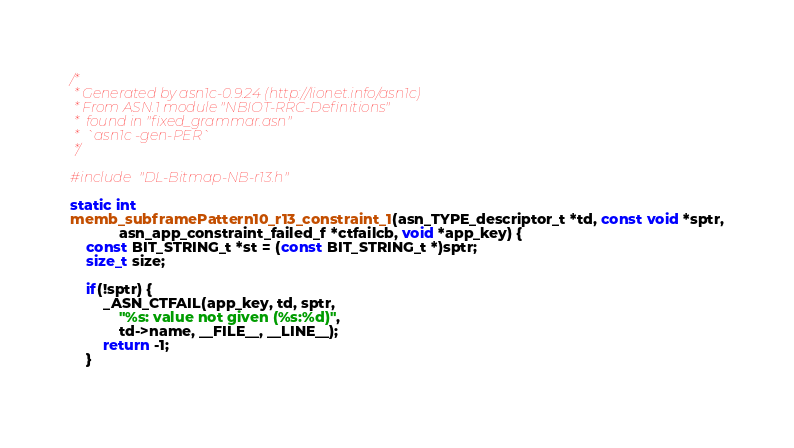<code> <loc_0><loc_0><loc_500><loc_500><_C_>/*
 * Generated by asn1c-0.9.24 (http://lionet.info/asn1c)
 * From ASN.1 module "NBIOT-RRC-Definitions"
 * 	found in "fixed_grammar.asn"
 * 	`asn1c -gen-PER`
 */

#include "DL-Bitmap-NB-r13.h"

static int
memb_subframePattern10_r13_constraint_1(asn_TYPE_descriptor_t *td, const void *sptr,
			asn_app_constraint_failed_f *ctfailcb, void *app_key) {
	const BIT_STRING_t *st = (const BIT_STRING_t *)sptr;
	size_t size;
	
	if(!sptr) {
		_ASN_CTFAIL(app_key, td, sptr,
			"%s: value not given (%s:%d)",
			td->name, __FILE__, __LINE__);
		return -1;
	}
	</code> 